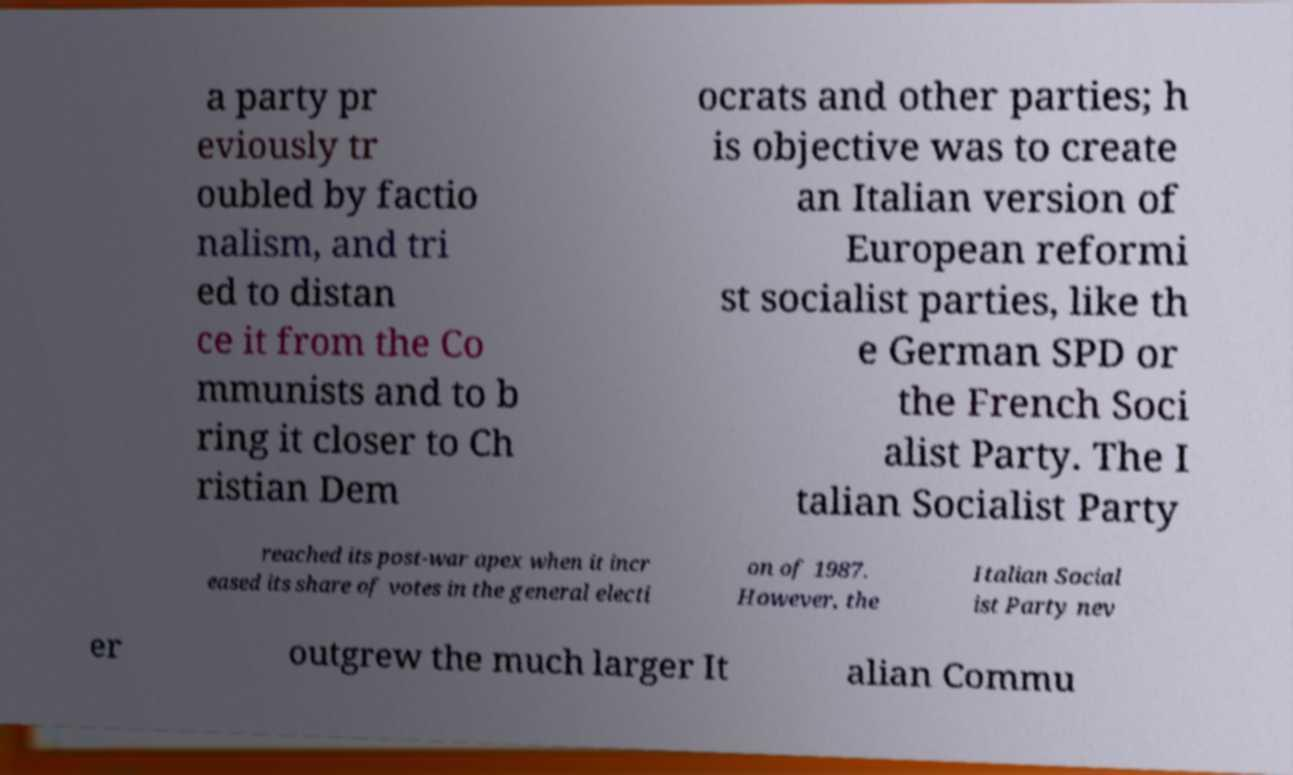Could you extract and type out the text from this image? a party pr eviously tr oubled by factio nalism, and tri ed to distan ce it from the Co mmunists and to b ring it closer to Ch ristian Dem ocrats and other parties; h is objective was to create an Italian version of European reformi st socialist parties, like th e German SPD or the French Soci alist Party. The I talian Socialist Party reached its post-war apex when it incr eased its share of votes in the general electi on of 1987. However, the Italian Social ist Party nev er outgrew the much larger It alian Commu 